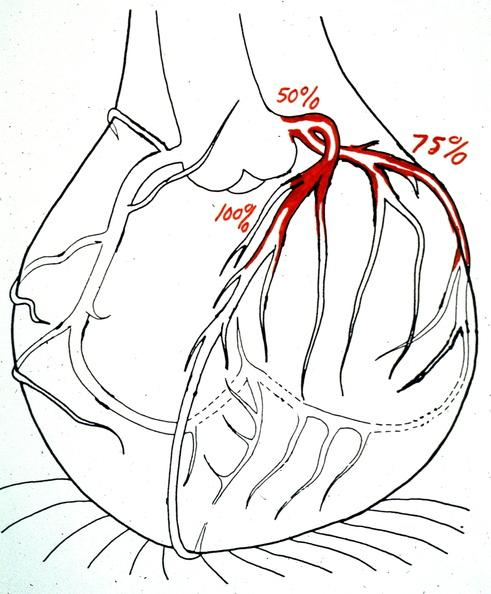does carcinoma show heart, myocardial infarction, map of coronary artery lesions?
Answer the question using a single word or phrase. No 